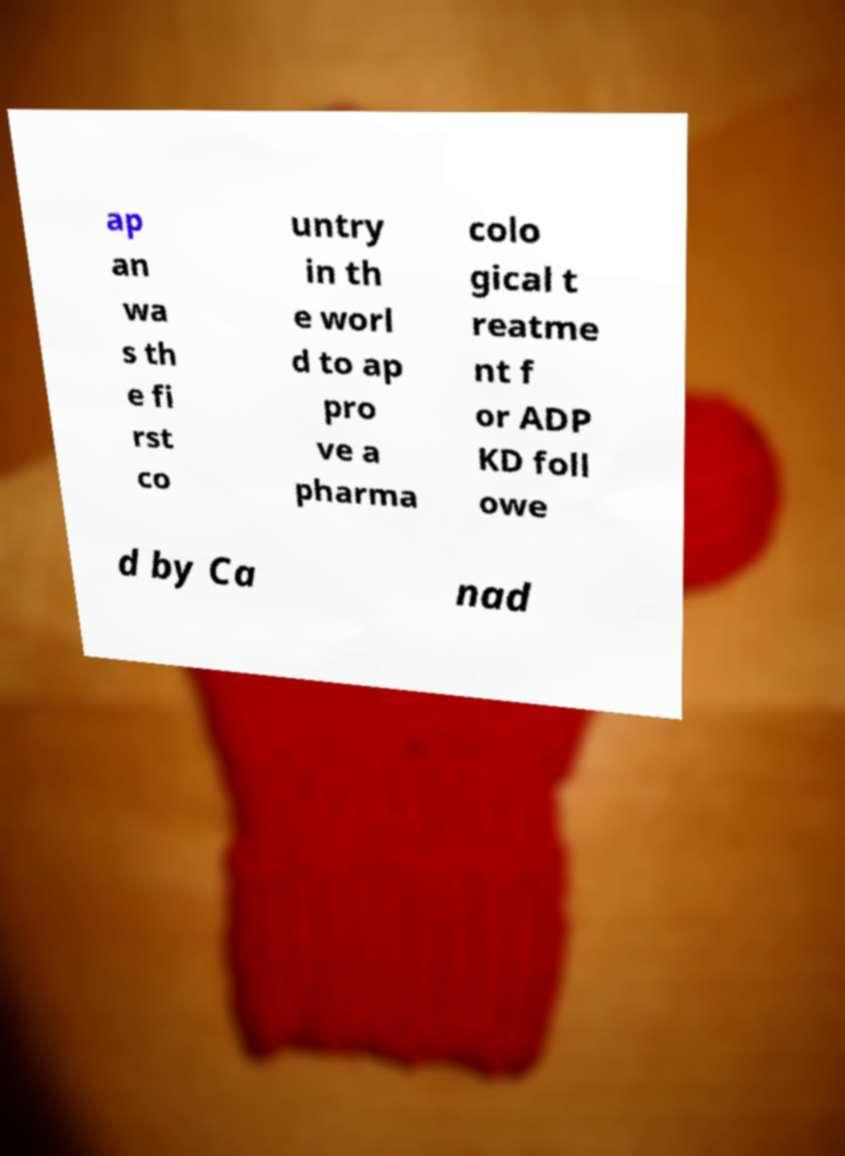Please read and relay the text visible in this image. What does it say? ap an wa s th e fi rst co untry in th e worl d to ap pro ve a pharma colo gical t reatme nt f or ADP KD foll owe d by Ca nad 